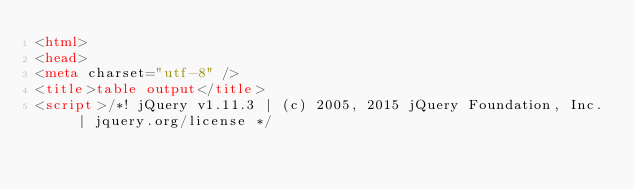<code> <loc_0><loc_0><loc_500><loc_500><_HTML_><html>
<head>
<meta charset="utf-8" />
<title>table output</title>
<script>/*! jQuery v1.11.3 | (c) 2005, 2015 jQuery Foundation, Inc. | jquery.org/license */</code> 